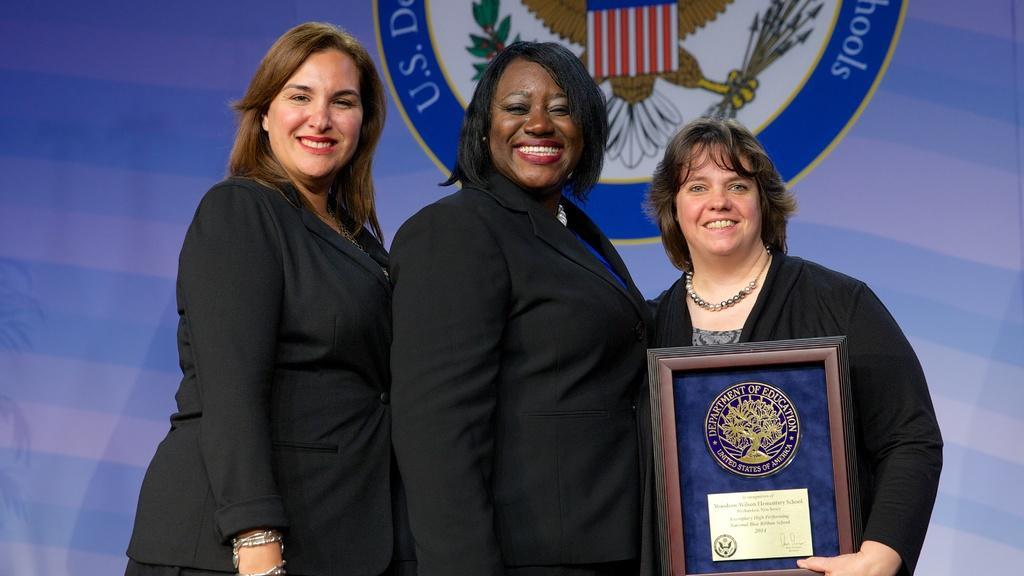In one or two sentences, can you explain what this image depicts? In this picture we can see women, they are smiling and one woman is holding an award and in the background we can see a curtain. 